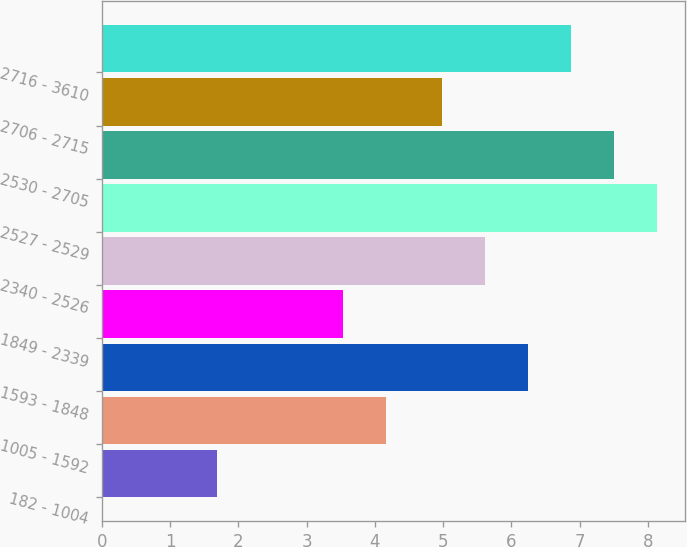Convert chart to OTSL. <chart><loc_0><loc_0><loc_500><loc_500><bar_chart><fcel>182 - 1004<fcel>1005 - 1592<fcel>1593 - 1848<fcel>1849 - 2339<fcel>2340 - 2526<fcel>2527 - 2529<fcel>2530 - 2705<fcel>2706 - 2715<fcel>2716 - 3610<nl><fcel>1.68<fcel>4.16<fcel>6.24<fcel>3.53<fcel>5.61<fcel>8.13<fcel>7.5<fcel>4.98<fcel>6.87<nl></chart> 